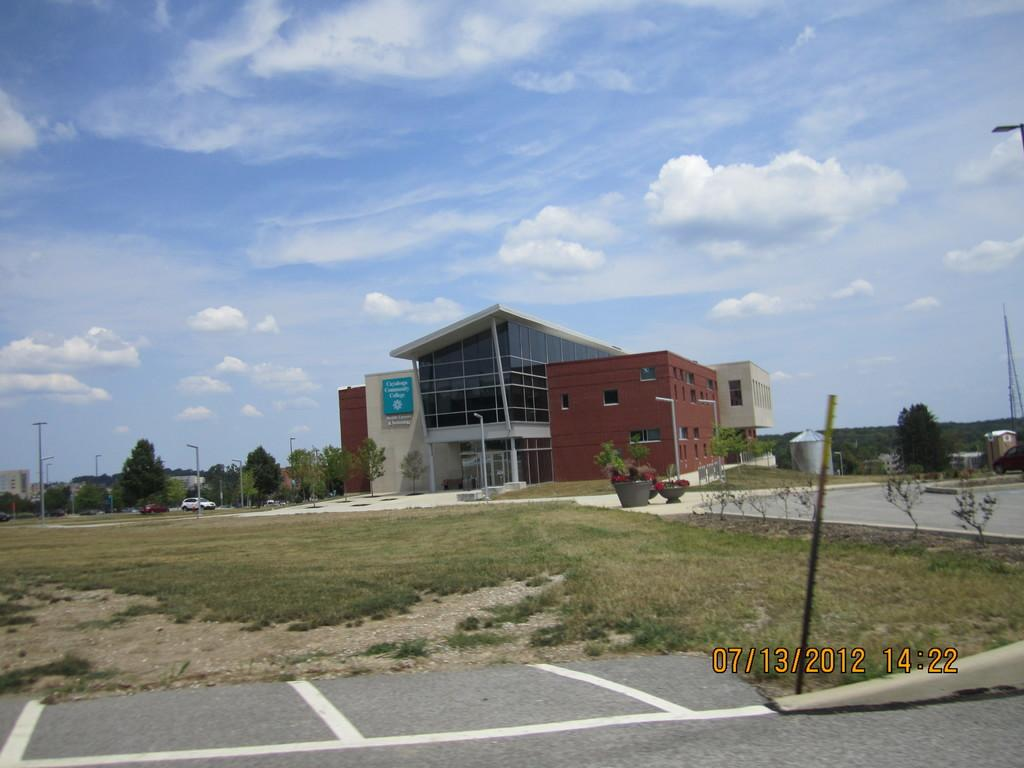What is the main feature of the image? There is a road in the image. What is the ground surface like? The ground is covered with grass. Are there any objects containing plants in the image? Yes, there are flower pots in the image. What can be seen in the distance? Buildings, trees, and poles are visible in the background. How would you describe the sky in the image? The sky is blue. How does the knee of the person walking on the road affect the balance of the image? There is no person walking on the road in the image, so the knee and balance of a person cannot be assessed. 